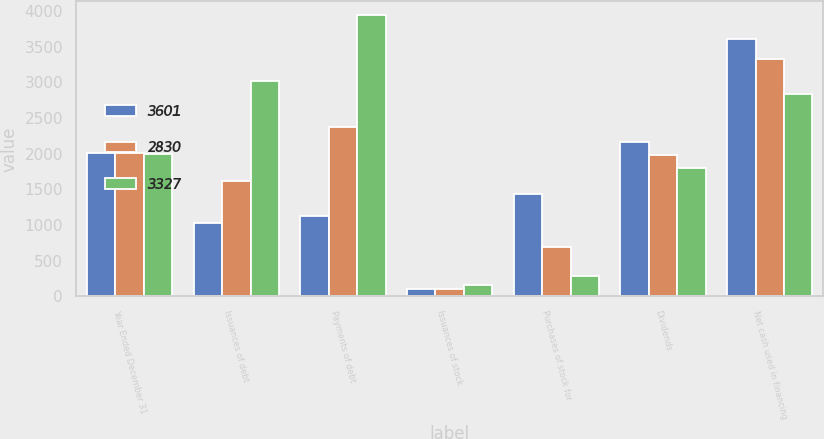Convert chart. <chart><loc_0><loc_0><loc_500><loc_500><stacked_bar_chart><ecel><fcel>Year Ended December 31<fcel>Issuances of debt<fcel>Payments of debt<fcel>Issuances of stock<fcel>Purchases of stock for<fcel>Dividends<fcel>Net cash used in financing<nl><fcel>3601<fcel>2003<fcel>1026<fcel>1119<fcel>98<fcel>1440<fcel>2166<fcel>3601<nl><fcel>2830<fcel>2002<fcel>1622<fcel>2378<fcel>107<fcel>691<fcel>1987<fcel>3327<nl><fcel>3327<fcel>2001<fcel>3011<fcel>3937<fcel>164<fcel>277<fcel>1791<fcel>2830<nl></chart> 